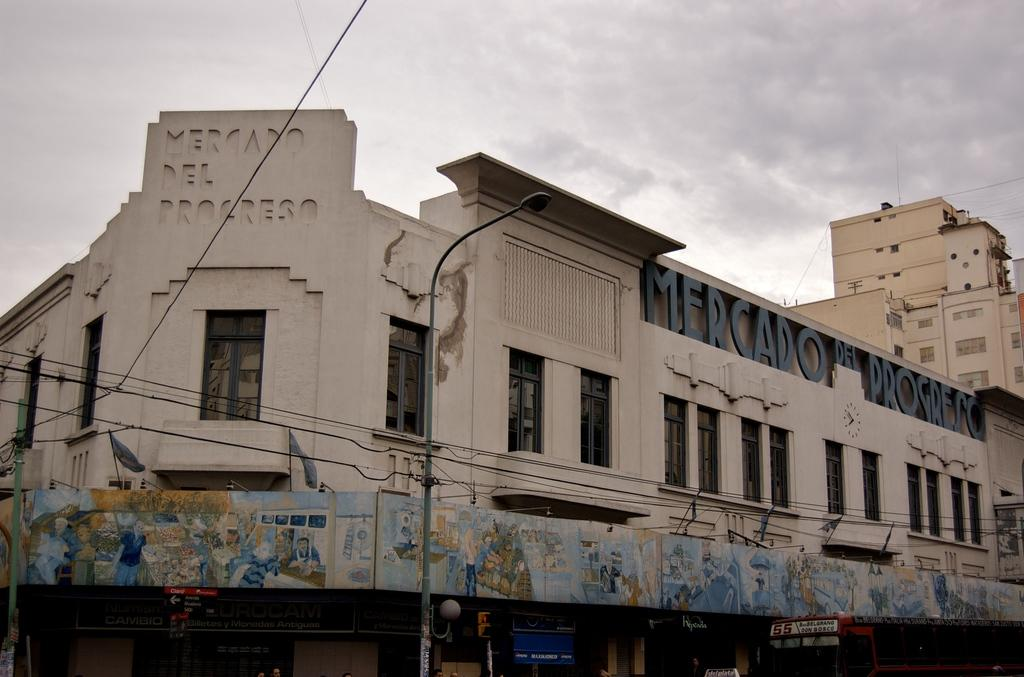What type of structure is visible in the image? There is a building in the image. What is located below the building? There is a vehicle below the building. What other objects related to traffic can be seen in the image? There is a traffic signal pole and a street light in the image. What can be seen on the right side of the image? There is another tall building on the right side of the image. How many lamps are hanging from the windows in the image? There are no lamps hanging from the windows in the image. What type of waste is visible on the street in the image? There is no waste visible on the street in the image. 